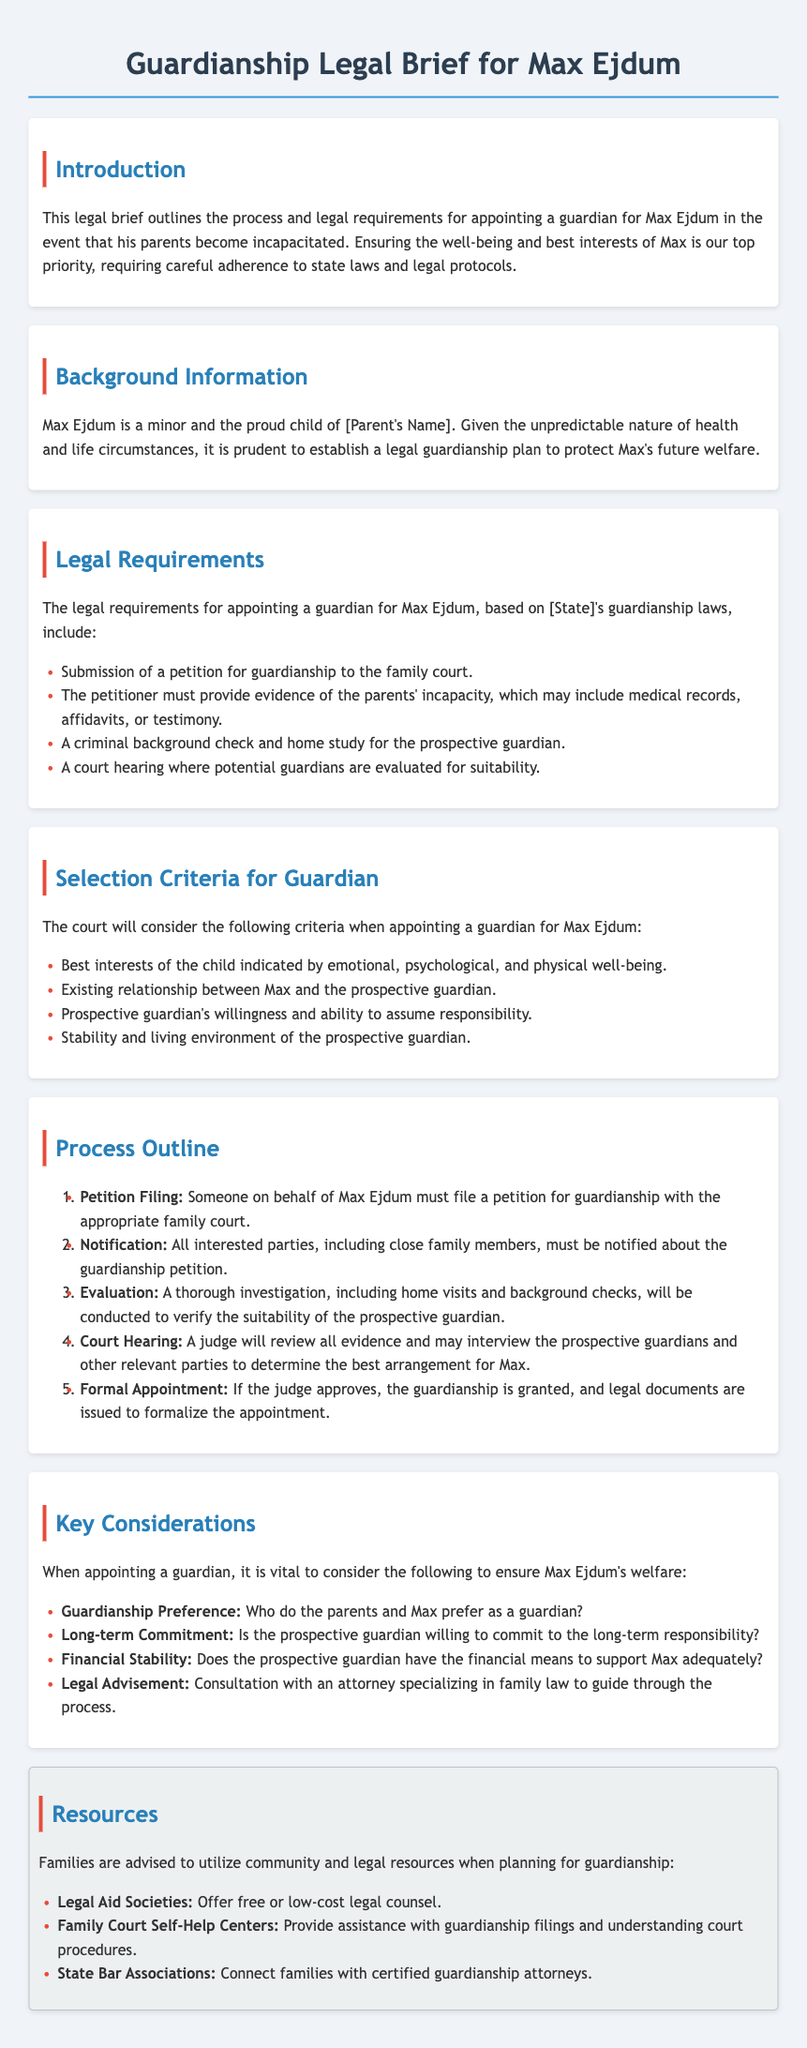What is the title of the legal brief? The title of the legal brief is a stated header in the document.
Answer: Guardianship Legal Brief for Max Ejdum Who is the minor mentioned in the legal brief? The document identifies Max Ejdum in the introduction section.
Answer: Max Ejdum What must be submitted to the family court for guardianship? The legal requirement specifies a document to be filed as part of the guardianship process.
Answer: Petition for guardianship Which check is required for the prospective guardian? This is mentioned within the legal requirements section that outlines necessary evaluations.
Answer: Criminal background check What does the first step in the process outline involve? The process outline provides the specific steps required for appointing a guardian.
Answer: Petition Filing What kind of assistance is suggested for families when planning for guardianship? The document lists resources available to families to navigate the guardianship process.
Answer: Legal Aid Societies Which factor is considered in selecting a guardian? This is part of the evaluation criteria listed for appointment.
Answer: Best interests of the child What is a key consideration for a prospective guardian's commitment? This pertains to the long-term responsibilities discussed in the key considerations section.
Answer: Long-term Commitment 